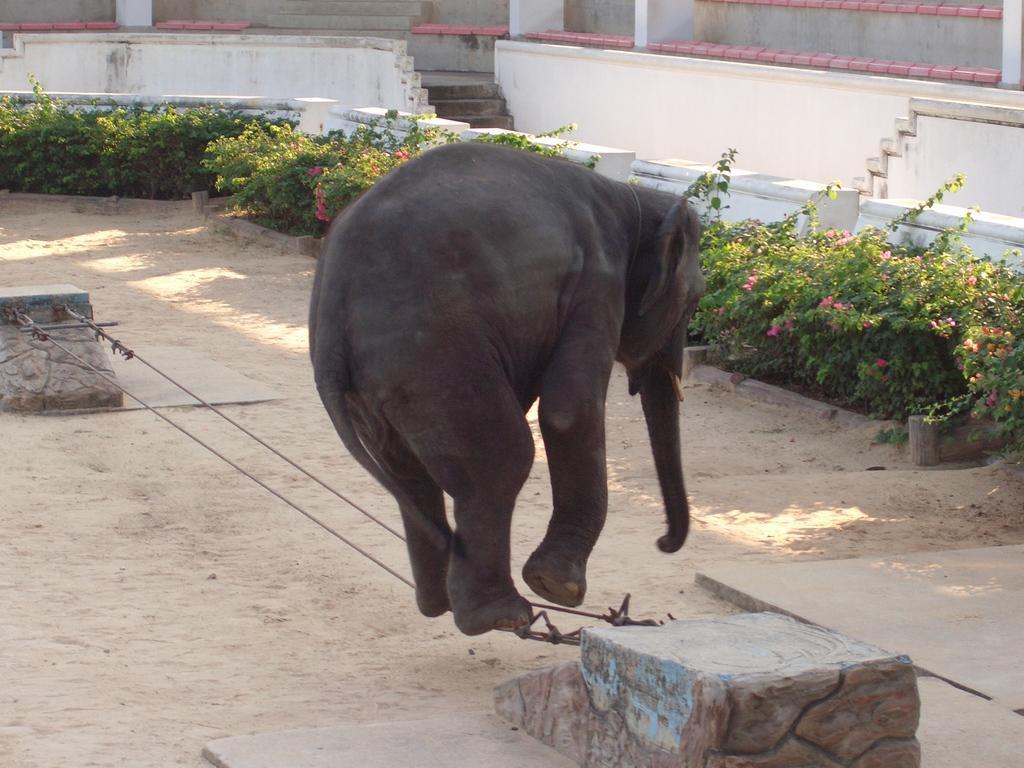Could you give a brief overview of what you see in this image? In the image in the center we can see one elephant on the rope. In the background there is a wall,staircase,fence,sand,plants,flowers etc. 